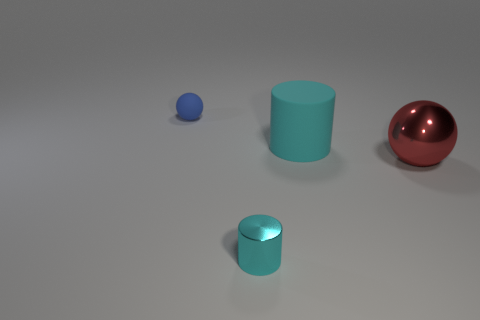Add 3 big red rubber balls. How many objects exist? 7 Subtract 2 spheres. How many spheres are left? 0 Subtract all blue cylinders. Subtract all red blocks. How many cylinders are left? 2 Subtract all gray cubes. How many blue spheres are left? 1 Subtract all large brown metallic cubes. Subtract all cylinders. How many objects are left? 2 Add 3 matte balls. How many matte balls are left? 4 Add 4 big matte objects. How many big matte objects exist? 5 Subtract 0 green cylinders. How many objects are left? 4 